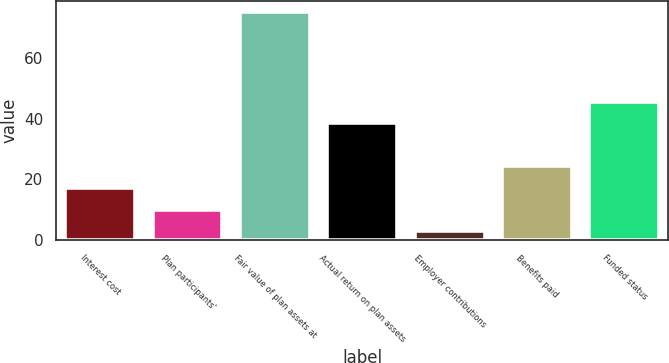Convert chart. <chart><loc_0><loc_0><loc_500><loc_500><bar_chart><fcel>Interest cost<fcel>Plan participants'<fcel>Fair value of plan assets at<fcel>Actual return on plan assets<fcel>Employer contributions<fcel>Benefits paid<fcel>Funded status<nl><fcel>17.2<fcel>10.1<fcel>75.1<fcel>38.5<fcel>3<fcel>24.3<fcel>45.6<nl></chart> 